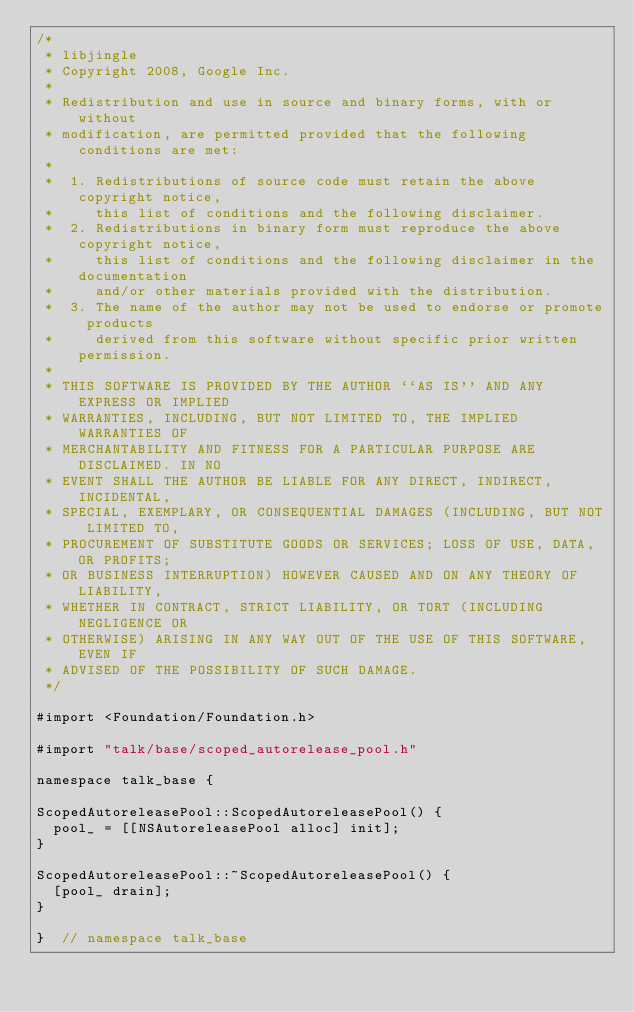Convert code to text. <code><loc_0><loc_0><loc_500><loc_500><_ObjectiveC_>/*
 * libjingle
 * Copyright 2008, Google Inc.
 *
 * Redistribution and use in source and binary forms, with or without
 * modification, are permitted provided that the following conditions are met:
 *
 *  1. Redistributions of source code must retain the above copyright notice,
 *     this list of conditions and the following disclaimer.
 *  2. Redistributions in binary form must reproduce the above copyright notice,
 *     this list of conditions and the following disclaimer in the documentation
 *     and/or other materials provided with the distribution.
 *  3. The name of the author may not be used to endorse or promote products
 *     derived from this software without specific prior written permission.
 *
 * THIS SOFTWARE IS PROVIDED BY THE AUTHOR ``AS IS'' AND ANY EXPRESS OR IMPLIED
 * WARRANTIES, INCLUDING, BUT NOT LIMITED TO, THE IMPLIED WARRANTIES OF
 * MERCHANTABILITY AND FITNESS FOR A PARTICULAR PURPOSE ARE DISCLAIMED. IN NO
 * EVENT SHALL THE AUTHOR BE LIABLE FOR ANY DIRECT, INDIRECT, INCIDENTAL,
 * SPECIAL, EXEMPLARY, OR CONSEQUENTIAL DAMAGES (INCLUDING, BUT NOT LIMITED TO,
 * PROCUREMENT OF SUBSTITUTE GOODS OR SERVICES; LOSS OF USE, DATA, OR PROFITS;
 * OR BUSINESS INTERRUPTION) HOWEVER CAUSED AND ON ANY THEORY OF LIABILITY,
 * WHETHER IN CONTRACT, STRICT LIABILITY, OR TORT (INCLUDING NEGLIGENCE OR
 * OTHERWISE) ARISING IN ANY WAY OUT OF THE USE OF THIS SOFTWARE, EVEN IF
 * ADVISED OF THE POSSIBILITY OF SUCH DAMAGE.
 */

#import <Foundation/Foundation.h>

#import "talk/base/scoped_autorelease_pool.h"

namespace talk_base {

ScopedAutoreleasePool::ScopedAutoreleasePool() {
  pool_ = [[NSAutoreleasePool alloc] init];
}

ScopedAutoreleasePool::~ScopedAutoreleasePool() {
  [pool_ drain];
}

}  // namespace talk_base
</code> 